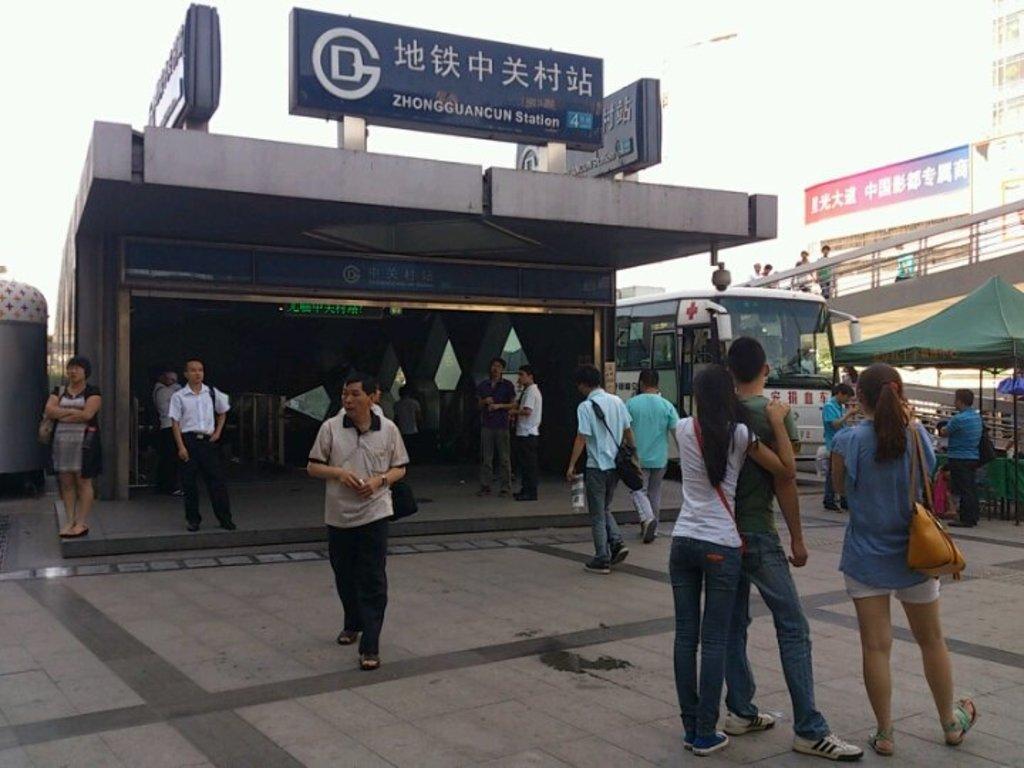Can you describe this image briefly? In this image, in the middle there is a man, he wears a t shirt, trouser, he is walking. On the right there are three people, they are standing. In the background there are people, buildings, tent, house, boards, posters, bus, road, sky. 